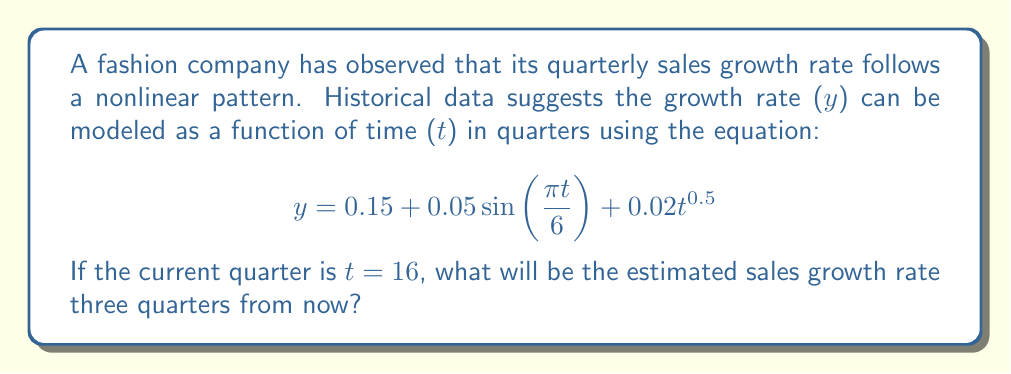Could you help me with this problem? To solve this problem, we need to follow these steps:

1. Identify the quarter we're forecasting:
   Current quarter: t = 16
   Quarters ahead: 3
   Target quarter: t = 16 + 3 = 19

2. Substitute t = 19 into the given equation:
   $$ y = 0.15 + 0.05 \sin(\frac{\pi \cdot 19}{6}) + 0.02 \cdot 19^{0.5} $$

3. Evaluate the sine term:
   $\frac{\pi \cdot 19}{6} \approx 9.9483$
   $\sin(9.9483) \approx -0.2840$

4. Evaluate the square root term:
   $19^{0.5} \approx 4.3589$

5. Calculate the final result:
   $$ y = 0.15 + 0.05(-0.2840) + 0.02(4.3589) $$
   $$ y = 0.15 - 0.0142 + 0.0872 $$
   $$ y = 0.2230 $$

6. Convert to percentage:
   0.2230 * 100% = 22.30%
Answer: 22.30% 